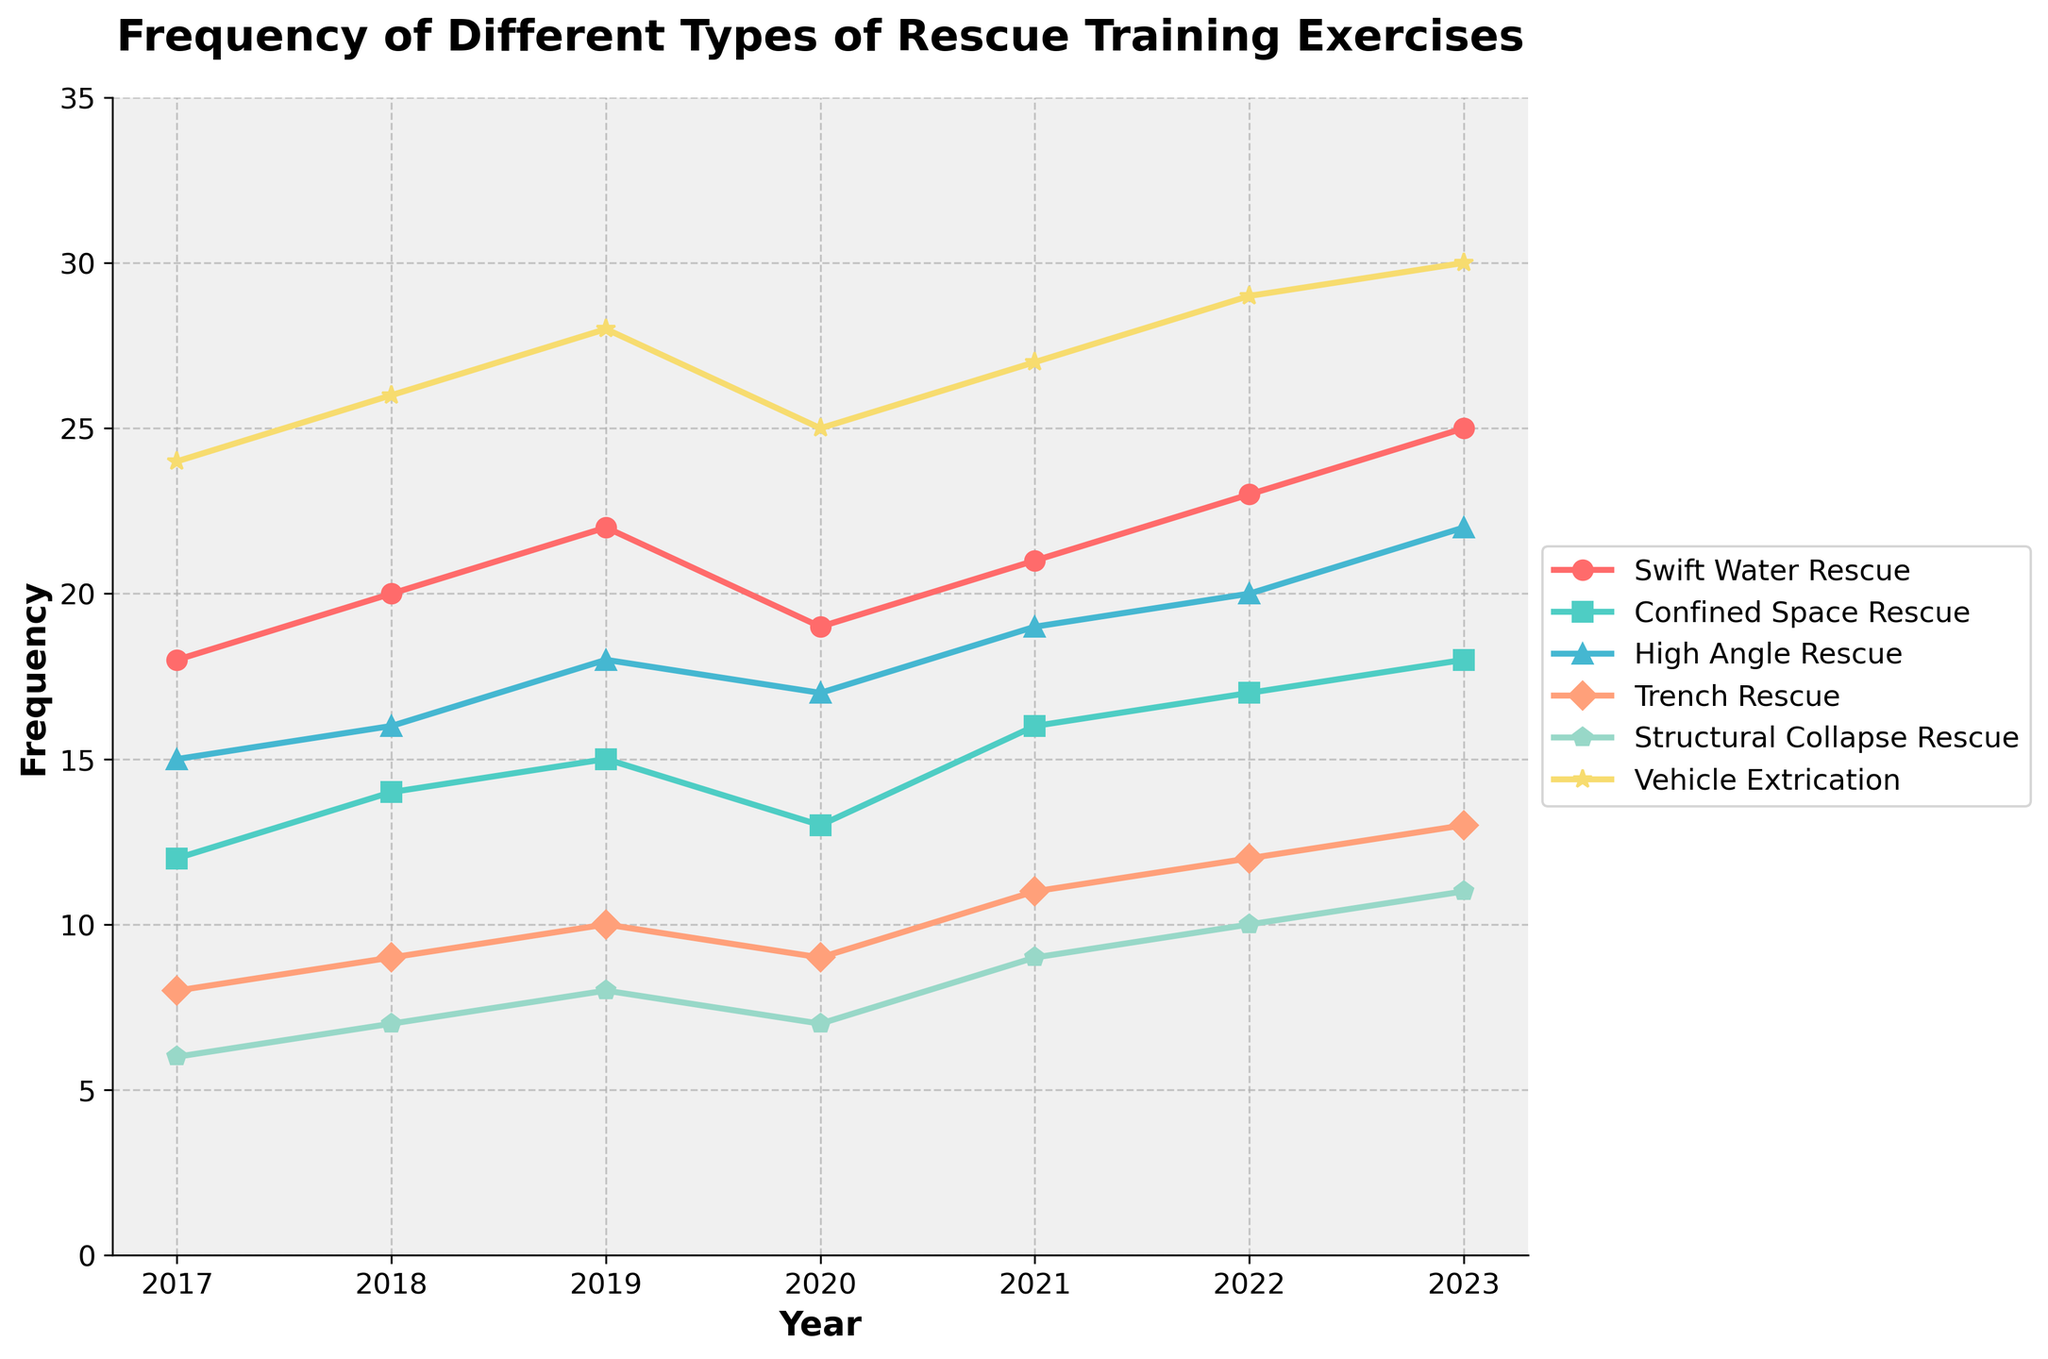What was the frequency of Swift Water Rescue training exercises in 2020? Look at the year 2020 on the x-axis and track the Swift Water Rescue data series (e.g., with markers). The point corresponding to 2020 shows a value of 19.
Answer: 19 Which rescue training exercise had the lowest frequency in 2023? Compare the frequencies of all training exercises in 2023. The exercise with the lowest value on the y-axis is Structural Collapse Rescue with a frequency of 11.
Answer: Structural Collapse Rescue What is the difference in the frequency of Trench Rescue training exercises between 2020 and 2023? Determine the Trench Rescue frequencies for 2020 and 2023 from the figure. Subtract the frequency in 2020 (9) from the frequency in 2023 (13). 13 - 9 = 4
Answer: 4 Between which two consecutive years did Vehicle Extrication training exercises see the largest increase? Analyze the year-to-year changes in Vehicle Extrication frequencies by calculating the differences: 
2017 to 2018: 26 - 24 = 2;
2018 to 2019: 28 - 26 = 2;
2019 to 2020: 25 - 28 = -3;
2020 to 2021: 27 - 25 = 2;
2021 to 2022: 29 - 27 = 2;
2022 to 2023: 30 - 29 = 1;
The largest increase is between 2018 and 2019 and between 2020 and 2021 at 2 each.
Answer: 2018 to 2019 and 2020 to 2021 What is the average frequency of Confined Space Rescue training exercises over the period from 2017 to 2023? Sum the Confined Space Rescue frequencies for each year (12 + 14 + 15 + 13 + 16 + 17 + 18 = 105) and divide by the number of years (7). 105 / 7 = 15
Answer: 15 Which rescue training exercise exhibited the most consistent trend over the years as per the plot? Look for the exercise with the least variation or most steady incline in the plotted lines. High Angle Rescue shows a steady incline without much fluctuation.
Answer: High Angle Rescue How much did the frequency of Structural Collapse Rescue training exercises increase from 2019 to 2022? Identify the frequencies in 2019 and 2022; Structural Collapse Rescue frequencies are 8 and 10 respectively. Compute the difference: 10 - 8 = 2
Answer: 2 Which rescue training exercise had the highest frequency in 2019? Examine the frequencies for all training exercises in 2019. Vehicle Extrication has the highest frequency of 28.
Answer: Vehicle Extrication In which year did Swift Water Rescue training exercises surpass 20 for the first time? Track the Swift Water Rescue data series and find the first year where the frequency exceeds 20. This occurred in 2019.
Answer: 2019 Comparing 2017 to 2023, which rescue training exercise had the largest absolute increase in frequency? Calculate the frequency differences for each exercise between 2017 and 2023:
Swift Water Rescue: 25 - 18 = 7;
Confined Space Rescue: 18 - 12 = 6;
High Angle Rescue: 22 - 15 = 7;
Trench Rescue: 13 - 8 = 5;
Structural Collapse Rescue: 11 - 6 = 5;
Vehicle Extrication: 30 - 24 = 6;
Both Swift Water Rescue and High Angle Rescue had the largest increase of 7.
Answer: Swift Water Rescue and High Angle Rescue 